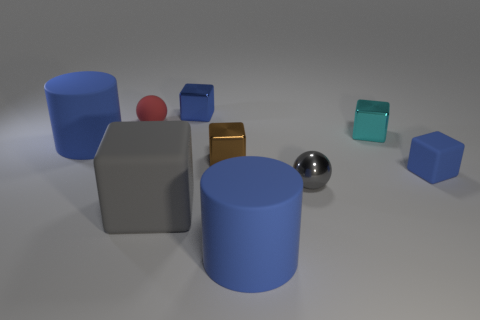The large thing on the left side of the tiny rubber object that is behind the tiny brown metallic thing is made of what material?
Offer a very short reply. Rubber. Is the number of metallic things on the right side of the tiny rubber sphere the same as the number of blue metal cubes?
Offer a very short reply. No. What is the size of the blue object that is both behind the small blue matte thing and to the right of the matte ball?
Offer a very short reply. Small. What is the color of the big matte cylinder that is in front of the sphere right of the rubber ball?
Provide a short and direct response. Blue. How many red objects are either big matte blocks or big things?
Offer a very short reply. 0. There is a matte object that is on the left side of the gray matte thing and in front of the rubber sphere; what color is it?
Your response must be concise. Blue. What number of big things are either shiny cubes or red balls?
Offer a terse response. 0. What is the size of the cyan object that is the same shape as the brown shiny thing?
Provide a succinct answer. Small. What is the shape of the tiny red object?
Your answer should be very brief. Sphere. Do the tiny cyan object and the big blue cylinder that is to the right of the large gray rubber thing have the same material?
Keep it short and to the point. No. 